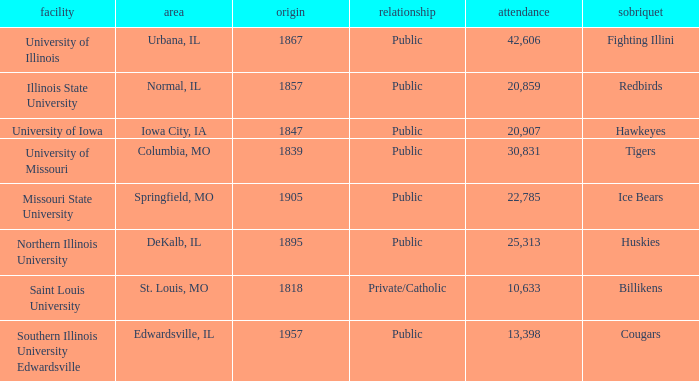Which institution is private/catholic? Saint Louis University. 